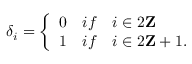Convert formula to latex. <formula><loc_0><loc_0><loc_500><loc_500>\delta _ { i } = \left \{ \begin{array} { l l } { 0 } & { { i f \quad i \in 2 { Z } } } \\ { 1 } & { { i f \quad i \in 2 { Z } + 1 . } } \end{array}</formula> 